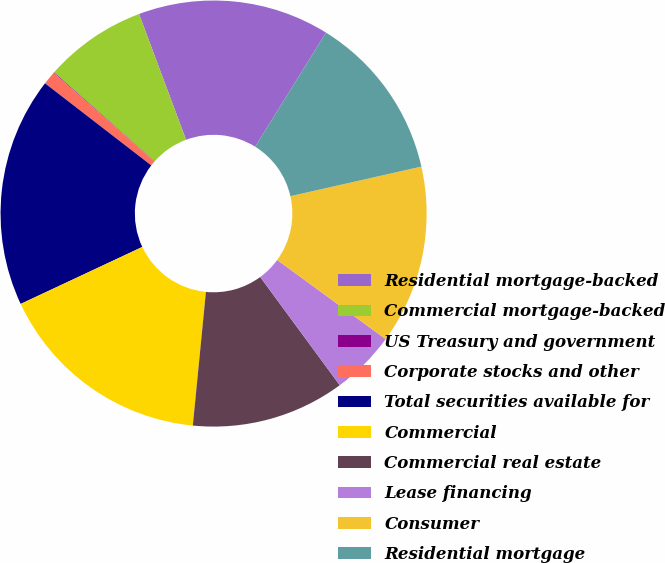Convert chart. <chart><loc_0><loc_0><loc_500><loc_500><pie_chart><fcel>Residential mortgage-backed<fcel>Commercial mortgage-backed<fcel>US Treasury and government<fcel>Corporate stocks and other<fcel>Total securities available for<fcel>Commercial<fcel>Commercial real estate<fcel>Lease financing<fcel>Consumer<fcel>Residential mortgage<nl><fcel>14.54%<fcel>7.78%<fcel>0.05%<fcel>1.01%<fcel>17.44%<fcel>16.47%<fcel>11.64%<fcel>4.88%<fcel>13.57%<fcel>12.61%<nl></chart> 